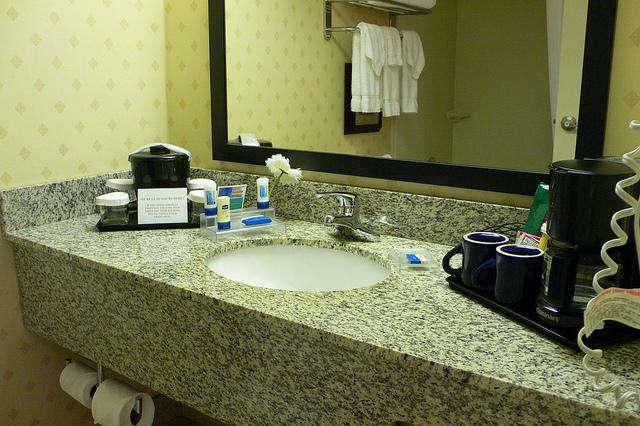What is in the cups by the sink?
Be succinct. Coffee. Is this in a home?
Be succinct. No. How many handles are on the faucet?
Answer briefly. 1. Where was the picture taken of the bathroom?
Be succinct. In bathroom. How many rolls of toilet paper are pictured?
Give a very brief answer. 2. 